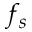Convert formula to latex. <formula><loc_0><loc_0><loc_500><loc_500>f _ { s }</formula> 